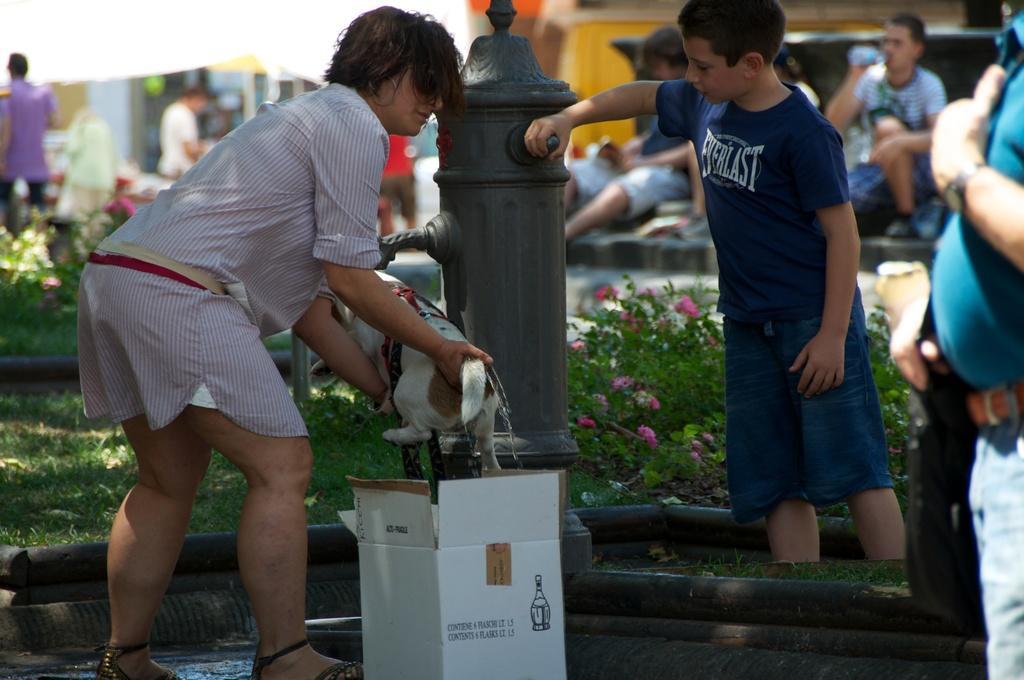Could you give a brief overview of what you see in this image? In this image, we can see people wearing clothes. There is a person on the left side of the image holding a dog with his hands. There is box at the bottom of the image. There is a water pump in the middle of the image. There are some plants beside the water pump. 